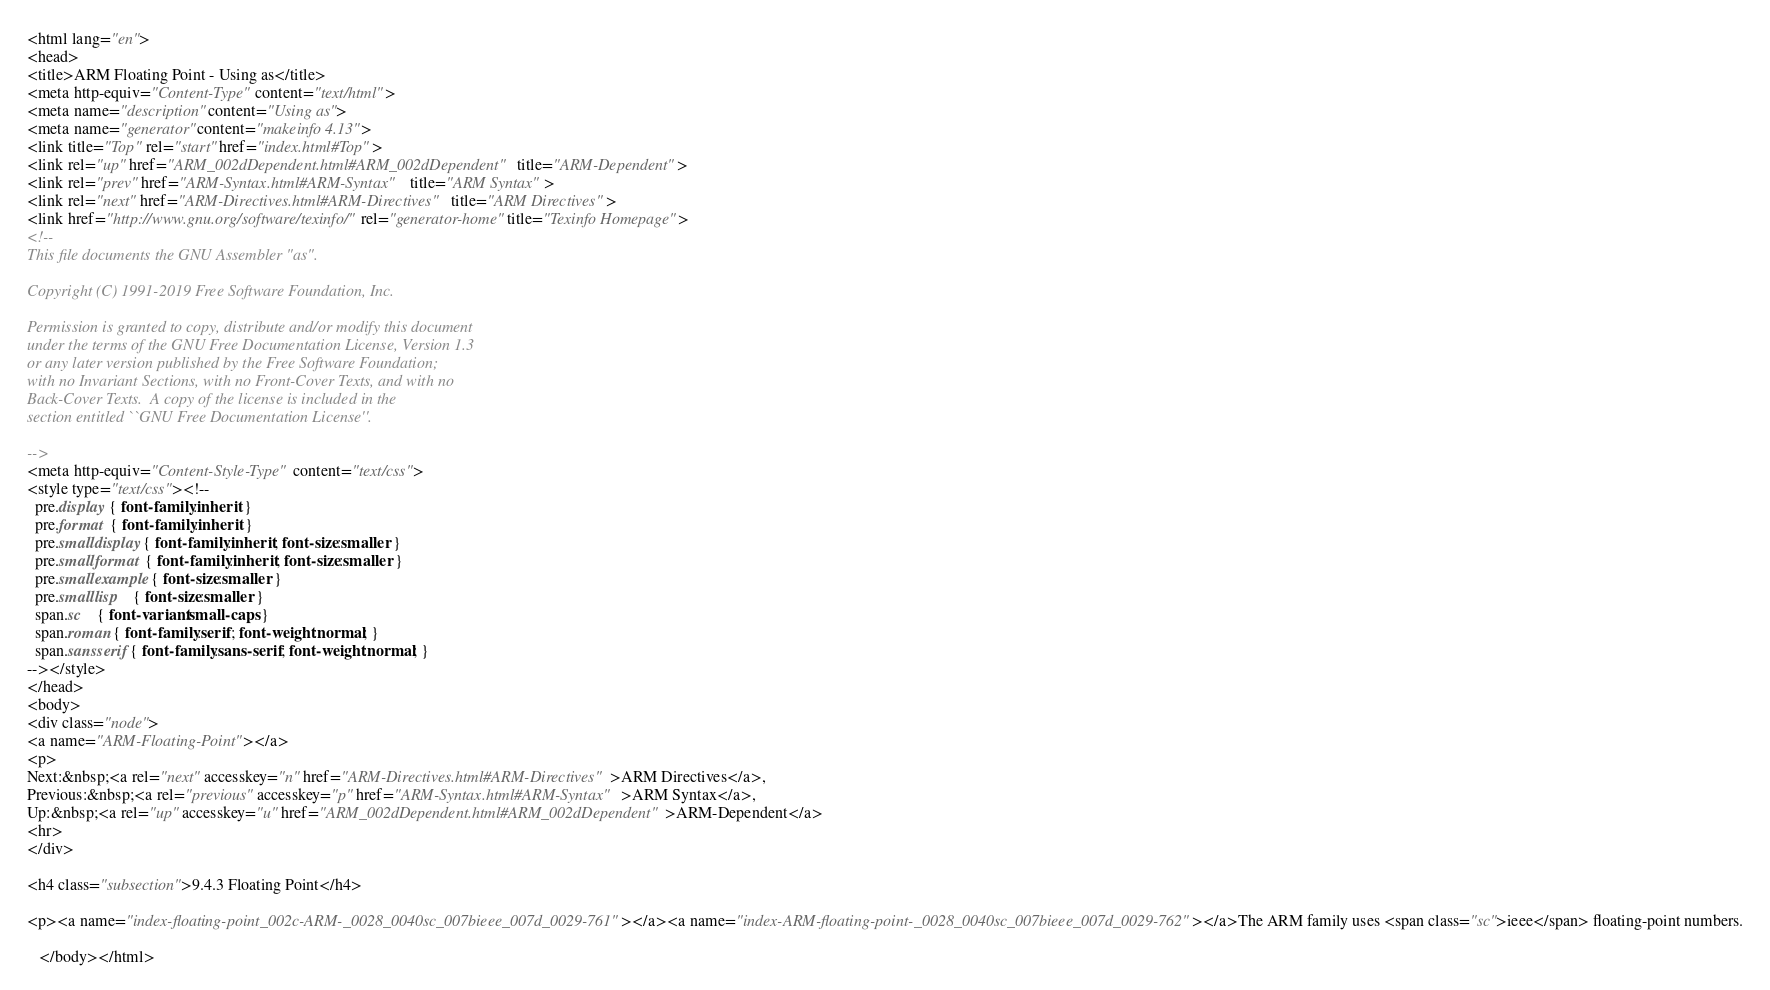<code> <loc_0><loc_0><loc_500><loc_500><_HTML_><html lang="en">
<head>
<title>ARM Floating Point - Using as</title>
<meta http-equiv="Content-Type" content="text/html">
<meta name="description" content="Using as">
<meta name="generator" content="makeinfo 4.13">
<link title="Top" rel="start" href="index.html#Top">
<link rel="up" href="ARM_002dDependent.html#ARM_002dDependent" title="ARM-Dependent">
<link rel="prev" href="ARM-Syntax.html#ARM-Syntax" title="ARM Syntax">
<link rel="next" href="ARM-Directives.html#ARM-Directives" title="ARM Directives">
<link href="http://www.gnu.org/software/texinfo/" rel="generator-home" title="Texinfo Homepage">
<!--
This file documents the GNU Assembler "as".

Copyright (C) 1991-2019 Free Software Foundation, Inc.

Permission is granted to copy, distribute and/or modify this document
under the terms of the GNU Free Documentation License, Version 1.3
or any later version published by the Free Software Foundation;
with no Invariant Sections, with no Front-Cover Texts, and with no
Back-Cover Texts.  A copy of the license is included in the
section entitled ``GNU Free Documentation License''.

-->
<meta http-equiv="Content-Style-Type" content="text/css">
<style type="text/css"><!--
  pre.display { font-family:inherit }
  pre.format  { font-family:inherit }
  pre.smalldisplay { font-family:inherit; font-size:smaller }
  pre.smallformat  { font-family:inherit; font-size:smaller }
  pre.smallexample { font-size:smaller }
  pre.smalllisp    { font-size:smaller }
  span.sc    { font-variant:small-caps }
  span.roman { font-family:serif; font-weight:normal; } 
  span.sansserif { font-family:sans-serif; font-weight:normal; } 
--></style>
</head>
<body>
<div class="node">
<a name="ARM-Floating-Point"></a>
<p>
Next:&nbsp;<a rel="next" accesskey="n" href="ARM-Directives.html#ARM-Directives">ARM Directives</a>,
Previous:&nbsp;<a rel="previous" accesskey="p" href="ARM-Syntax.html#ARM-Syntax">ARM Syntax</a>,
Up:&nbsp;<a rel="up" accesskey="u" href="ARM_002dDependent.html#ARM_002dDependent">ARM-Dependent</a>
<hr>
</div>

<h4 class="subsection">9.4.3 Floating Point</h4>

<p><a name="index-floating-point_002c-ARM-_0028_0040sc_007bieee_007d_0029-761"></a><a name="index-ARM-floating-point-_0028_0040sc_007bieee_007d_0029-762"></a>The ARM family uses <span class="sc">ieee</span> floating-point numbers.

   </body></html>

</code> 